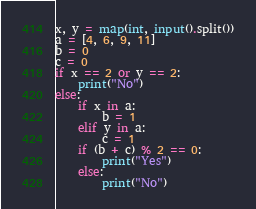Convert code to text. <code><loc_0><loc_0><loc_500><loc_500><_Python_>x, y = map(int, input().split())
a = [4, 6, 9, 11]
b = 0
c = 0
if x == 2 or y == 2:
    print("No")
else:
    if x in a:
        b = 1
    elif y in a:
        c = 1
    if (b + c) % 2 == 0:
        print("Yes")
    else:
        print("No")</code> 